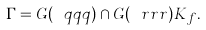<formula> <loc_0><loc_0><loc_500><loc_500>\Gamma = G ( \ q q q ) \cap G ( \ r r r ) K _ { f } .</formula> 